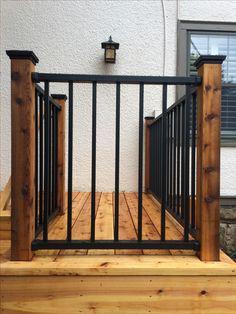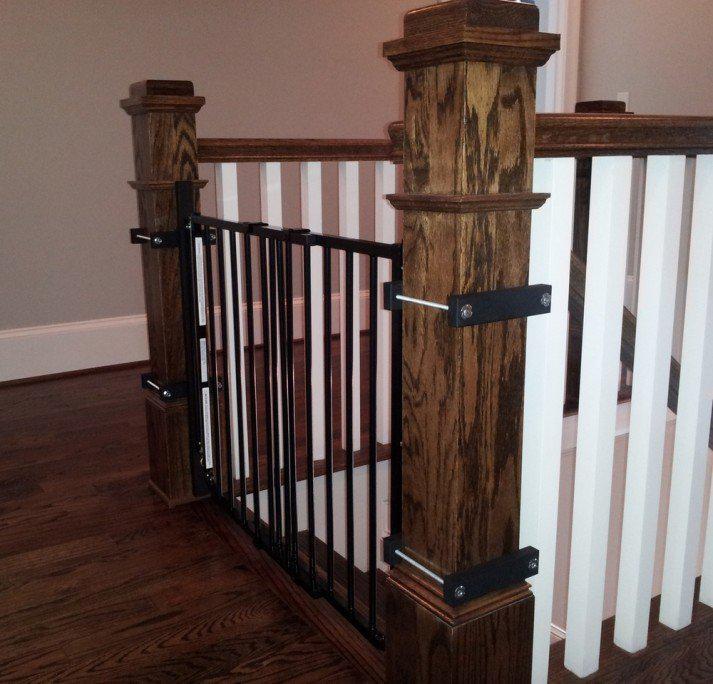The first image is the image on the left, the second image is the image on the right. Assess this claim about the two images: "The left image shows the inside of a corner of a railing.". Correct or not? Answer yes or no. No. The first image is the image on the left, the second image is the image on the right. Given the left and right images, does the statement "The left image features corner posts with square cap tops and straight black vertical bars with no embellishments." hold true? Answer yes or no. Yes. 